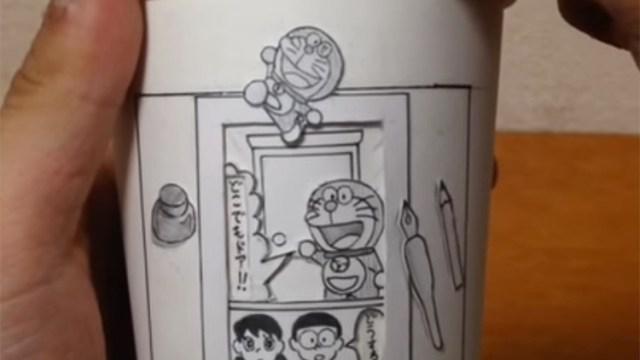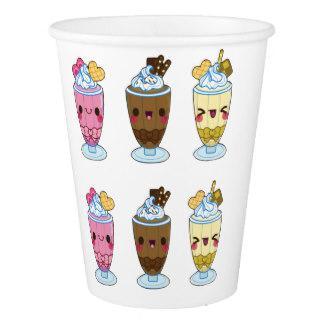The first image is the image on the left, the second image is the image on the right. Assess this claim about the two images: "In at least one image there are three paper cups.". Correct or not? Answer yes or no. No. The first image is the image on the left, the second image is the image on the right. Given the left and right images, does the statement "The left image shows a thumb on the left side of a cup, and the right image includes a cup with a cartoon face on it and contains no more than two cups." hold true? Answer yes or no. Yes. 